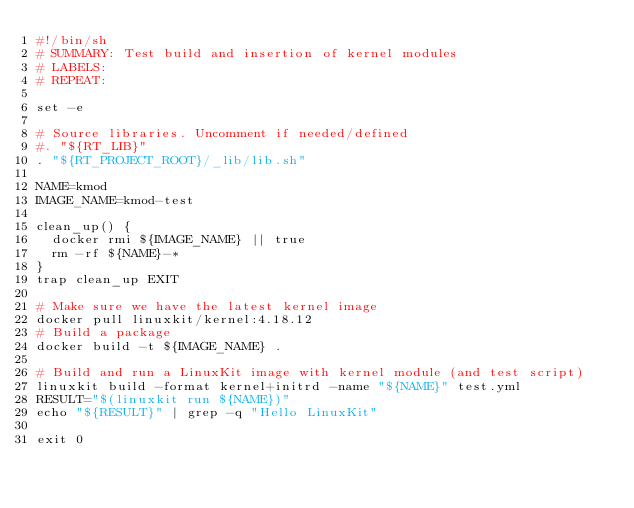Convert code to text. <code><loc_0><loc_0><loc_500><loc_500><_Bash_>#!/bin/sh
# SUMMARY: Test build and insertion of kernel modules
# LABELS:
# REPEAT:

set -e

# Source libraries. Uncomment if needed/defined
#. "${RT_LIB}"
. "${RT_PROJECT_ROOT}/_lib/lib.sh"

NAME=kmod
IMAGE_NAME=kmod-test

clean_up() {
	docker rmi ${IMAGE_NAME} || true
	rm -rf ${NAME}-*
}
trap clean_up EXIT

# Make sure we have the latest kernel image
docker pull linuxkit/kernel:4.18.12
# Build a package
docker build -t ${IMAGE_NAME} .

# Build and run a LinuxKit image with kernel module (and test script)
linuxkit build -format kernel+initrd -name "${NAME}" test.yml
RESULT="$(linuxkit run ${NAME})"
echo "${RESULT}" | grep -q "Hello LinuxKit"

exit 0
</code> 